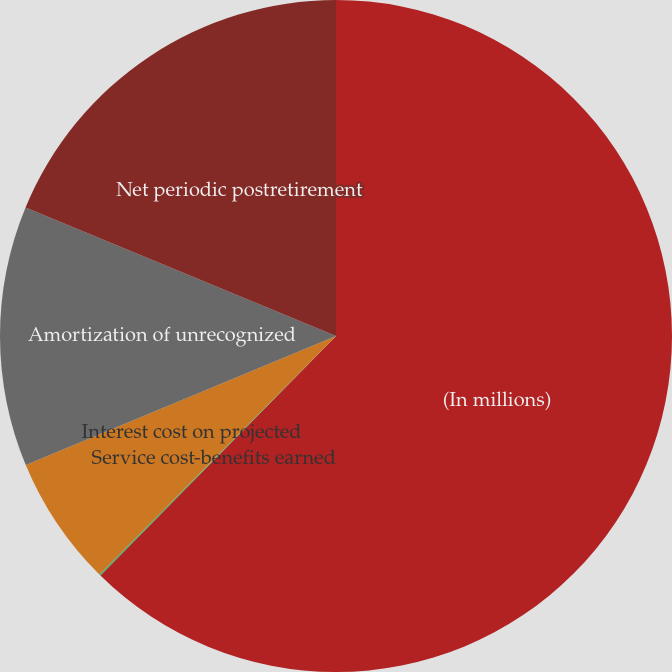<chart> <loc_0><loc_0><loc_500><loc_500><pie_chart><fcel>(In millions)<fcel>Service cost-benefits earned<fcel>Interest cost on projected<fcel>Amortization of unrecognized<fcel>Net periodic postretirement<nl><fcel>62.36%<fcel>0.07%<fcel>6.29%<fcel>12.52%<fcel>18.75%<nl></chart> 